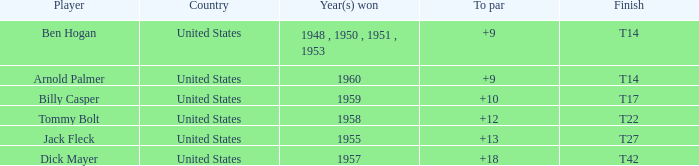What is Country, when Total is less than 290, and when Year(s) Won is 1960? United States. 